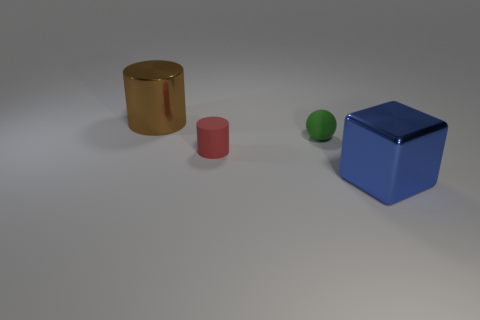Can you tell me about the colors and materials of the objects in this image? Certainly! There are four objects in the image, each with distinct colors and materials. To the far left, there's a shiny, reflective gold cylinder. Then there's a matte red cylinder with a duller finish, suggesting it could be plastic or painted metal. Next to it is a small green sphere with a rubbery texture that's noticeable due to its light-absorbing surface. Finally, we have a large blue cube that has a matte finish, which could imply that it's made of a non-reflective material like plastic or painted wood. 